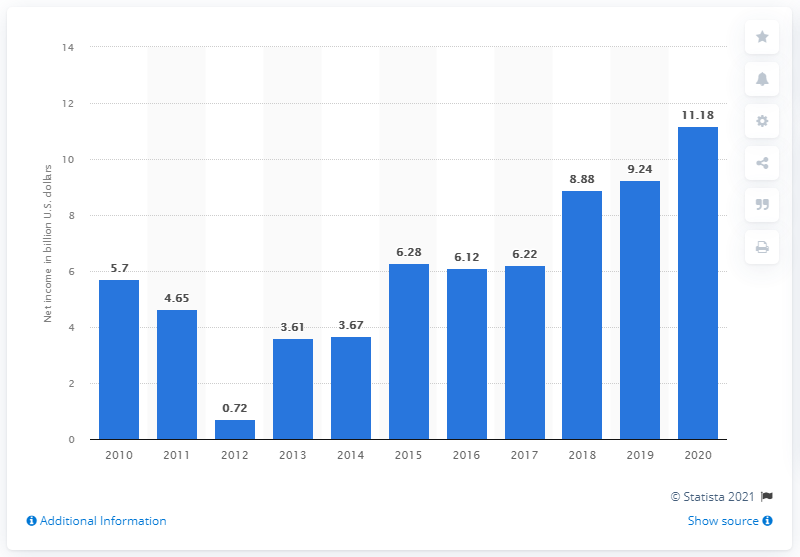Point out several critical features in this image. In 2020, Morgan Stanley's net income was 11.18 billion dollars. 